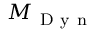Convert formula to latex. <formula><loc_0><loc_0><loc_500><loc_500>M _ { D y n }</formula> 